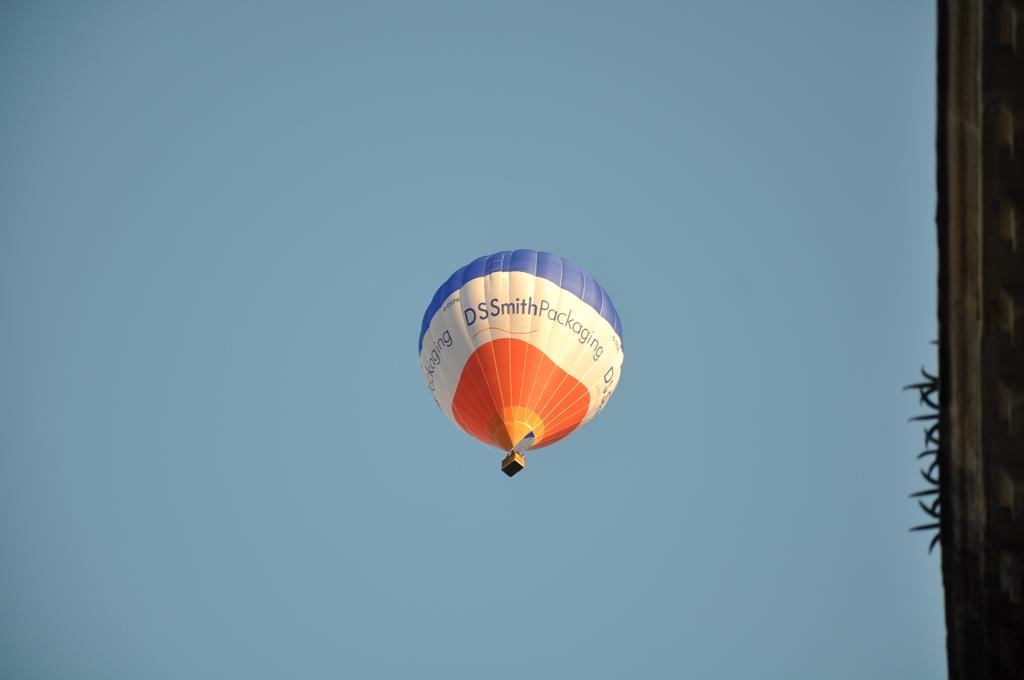<image>
Create a compact narrative representing the image presented. The red white and blue hot air balloon up in the sky is advertising DS Smith Packaging. 